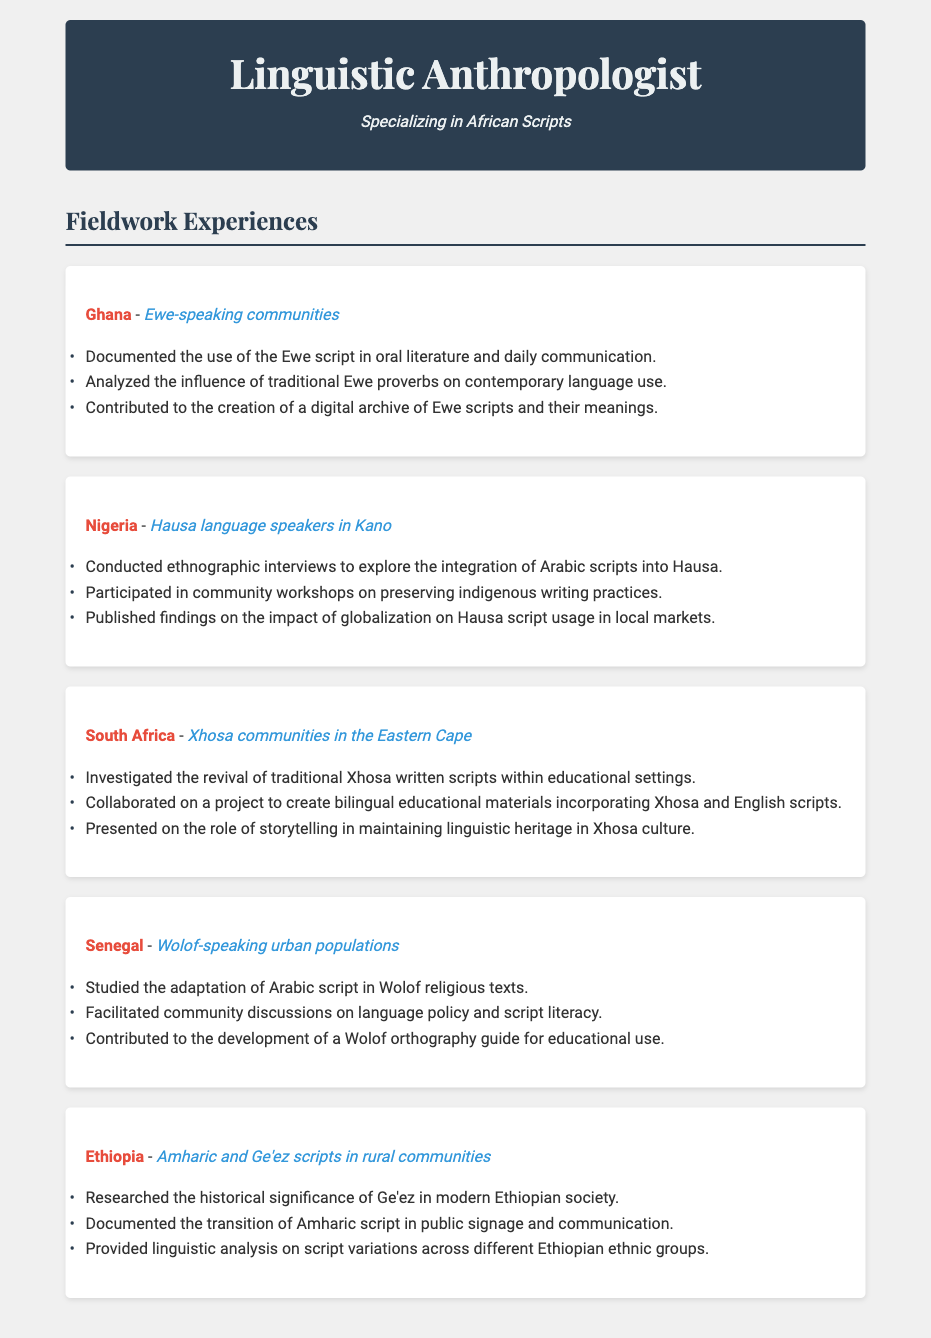What is the location of the first fieldwork experience? The first fieldwork experience is in Ghana, as listed in the document.
Answer: Ghana Which communities were engaged in Nigeria? The document specifies that the communities engaged in Nigeria are Hausa language speakers in Kano.
Answer: Hausa language speakers in Kano What was a linguistic contribution in the fieldwork conducted in Senegal? The document states that a linguistic contribution in Senegal included the development of a Wolof orthography guide for educational use.
Answer: Wolof orthography guide How many fieldwork experiences are detailed in the document? The document lists a total of five fieldwork experiences across various African regions.
Answer: Five What specific script was investigated in South Africa? The document mentions that the revival of traditional Xhosa written scripts was investigated in South Africa.
Answer: Traditional Xhosa written scripts Which language was documented in Ethiopia? The document indicates that both Amharic and Ge'ez scripts were documented in Ethiopia.
Answer: Amharic and Ge'ez What type of community discussions were facilitated in Senegal? The document notes that community discussions on language policy and script literacy were facilitated in Senegal.
Answer: Language policy and script literacy In which African region was the influence of traditional proverbs analyzed? The document states that the influence of traditional Ewe proverbs was analyzed in Ghana.
Answer: Ghana 